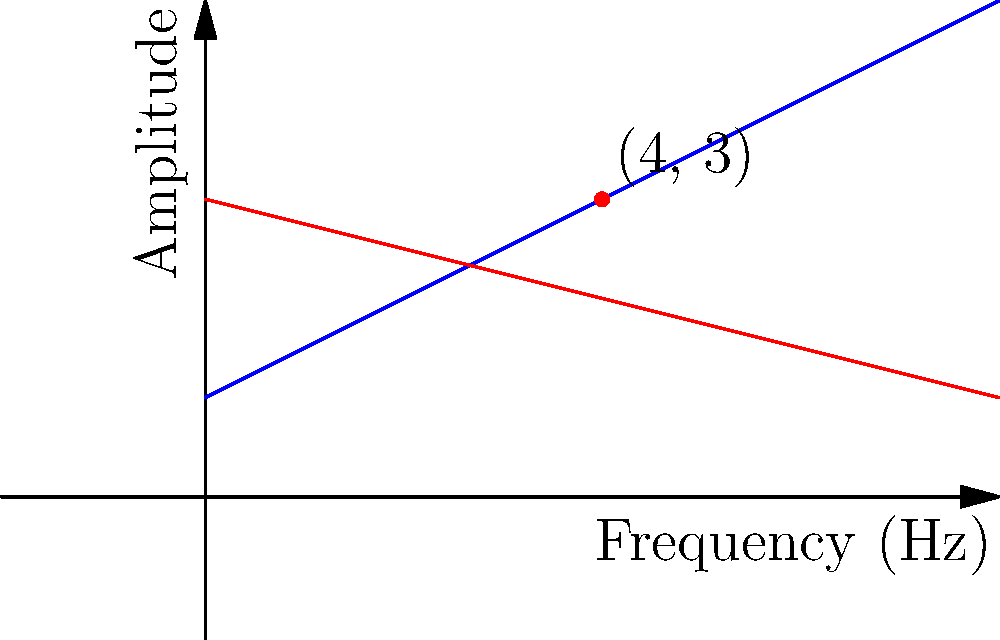In the Sheffield Sound Studio, two sound waves are represented by the following equations:

Wave 1: $y = 0.5x + 1$
Wave 2: $y = -0.25x + 3$

Where $x$ represents frequency (in Hz) and $y$ represents amplitude. At which frequency do these two sound waves intersect, potentially creating an interesting harmonic effect for a new Sheffield band's recording? To find the intersection point of these two lines (sound waves), we need to solve the system of equations:

$$\begin{cases}
y = 0.5x + 1 \\
y = -0.25x + 3
\end{cases}$$

Step 1: Set the equations equal to each other since they intersect at a point where y-values are the same.
$0.5x + 1 = -0.25x + 3$

Step 2: Solve for x by isolating all terms with x on one side and constants on the other.
$0.5x + 0.25x = 3 - 1$
$0.75x = 2$

Step 3: Divide both sides by 0.75 to isolate x.
$x = \frac{2}{0.75} = \frac{8}{3} = 4$

Step 4: Verify by substituting x = 4 into either of the original equations. Let's use Wave 1:
$y = 0.5(4) + 1 = 2 + 1 = 3$

Therefore, the intersection point is (4, 3), meaning the waves intersect at a frequency of 4 Hz.
Answer: 4 Hz 